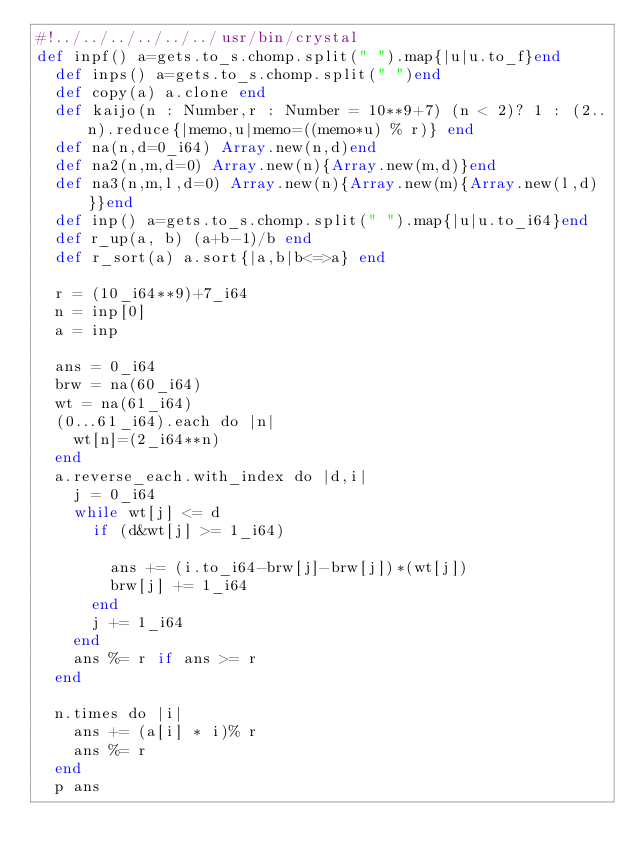Convert code to text. <code><loc_0><loc_0><loc_500><loc_500><_Crystal_>#!../../../../../../usr/bin/crystal
def inpf() a=gets.to_s.chomp.split(" ").map{|u|u.to_f}end
  def inps() a=gets.to_s.chomp.split(" ")end
  def copy(a) a.clone end
  def kaijo(n : Number,r : Number = 10**9+7) (n < 2)? 1 : (2..n).reduce{|memo,u|memo=((memo*u) % r)} end
  def na(n,d=0_i64) Array.new(n,d)end
  def na2(n,m,d=0) Array.new(n){Array.new(m,d)}end
  def na3(n,m,l,d=0) Array.new(n){Array.new(m){Array.new(l,d)}}end
  def inp() a=gets.to_s.chomp.split(" ").map{|u|u.to_i64}end
  def r_up(a, b) (a+b-1)/b end
  def r_sort(a) a.sort{|a,b|b<=>a} end

  r = (10_i64**9)+7_i64
  n = inp[0]
  a = inp
  
  ans = 0_i64
  brw = na(60_i64)
  wt = na(61_i64)
  (0...61_i64).each do |n|
    wt[n]=(2_i64**n)
  end
  a.reverse_each.with_index do |d,i|
    j = 0_i64
    while wt[j] <= d
      if (d&wt[j] >= 1_i64)

        ans += (i.to_i64-brw[j]-brw[j])*(wt[j])
        brw[j] += 1_i64
      end
      j += 1_i64
    end
    ans %= r if ans >= r
  end
  
  n.times do |i|
    ans += (a[i] * i)% r 
    ans %= r
  end
  p ans
  </code> 